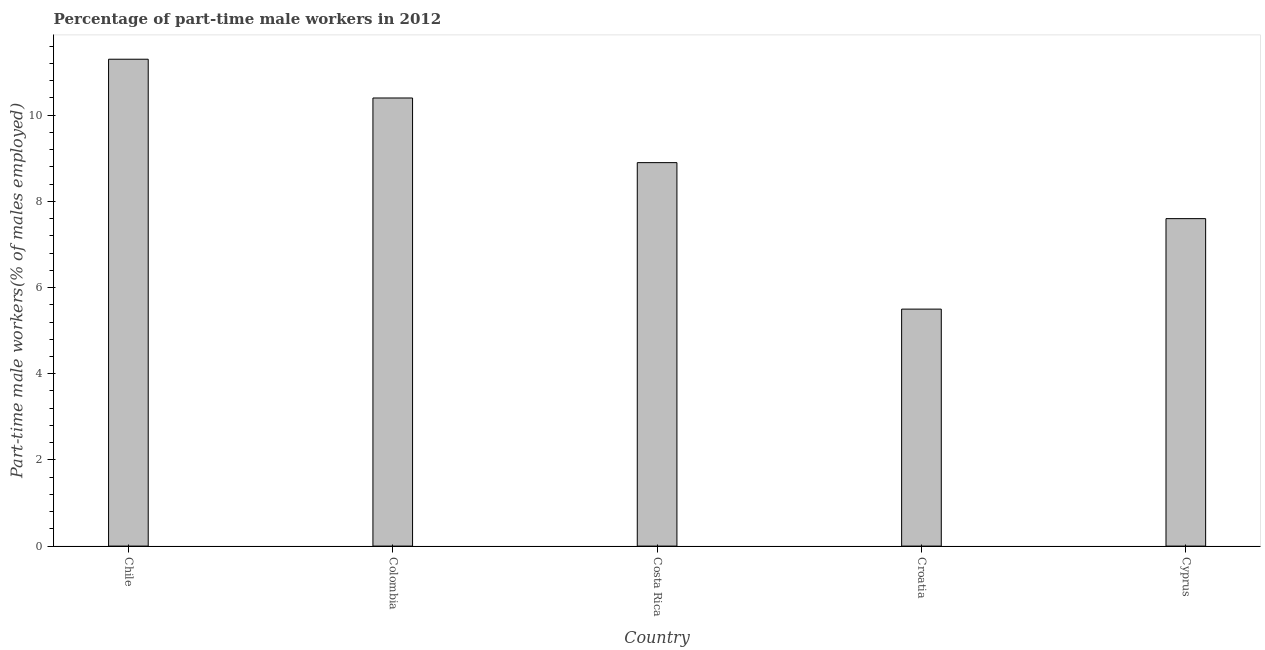What is the title of the graph?
Provide a succinct answer. Percentage of part-time male workers in 2012. What is the label or title of the Y-axis?
Your answer should be compact. Part-time male workers(% of males employed). Across all countries, what is the maximum percentage of part-time male workers?
Offer a terse response. 11.3. Across all countries, what is the minimum percentage of part-time male workers?
Offer a terse response. 5.5. In which country was the percentage of part-time male workers maximum?
Offer a terse response. Chile. In which country was the percentage of part-time male workers minimum?
Keep it short and to the point. Croatia. What is the sum of the percentage of part-time male workers?
Ensure brevity in your answer.  43.7. What is the average percentage of part-time male workers per country?
Offer a very short reply. 8.74. What is the median percentage of part-time male workers?
Ensure brevity in your answer.  8.9. What is the ratio of the percentage of part-time male workers in Chile to that in Croatia?
Offer a very short reply. 2.06. What is the difference between the highest and the second highest percentage of part-time male workers?
Make the answer very short. 0.9. Is the sum of the percentage of part-time male workers in Costa Rica and Croatia greater than the maximum percentage of part-time male workers across all countries?
Ensure brevity in your answer.  Yes. What is the difference between the highest and the lowest percentage of part-time male workers?
Offer a very short reply. 5.8. In how many countries, is the percentage of part-time male workers greater than the average percentage of part-time male workers taken over all countries?
Give a very brief answer. 3. How many bars are there?
Offer a very short reply. 5. What is the difference between two consecutive major ticks on the Y-axis?
Offer a terse response. 2. Are the values on the major ticks of Y-axis written in scientific E-notation?
Offer a terse response. No. What is the Part-time male workers(% of males employed) of Chile?
Your answer should be compact. 11.3. What is the Part-time male workers(% of males employed) of Colombia?
Make the answer very short. 10.4. What is the Part-time male workers(% of males employed) of Costa Rica?
Your answer should be very brief. 8.9. What is the Part-time male workers(% of males employed) of Croatia?
Provide a succinct answer. 5.5. What is the Part-time male workers(% of males employed) of Cyprus?
Offer a terse response. 7.6. What is the difference between the Part-time male workers(% of males employed) in Chile and Costa Rica?
Provide a short and direct response. 2.4. What is the difference between the Part-time male workers(% of males employed) in Chile and Croatia?
Your answer should be compact. 5.8. What is the difference between the Part-time male workers(% of males employed) in Chile and Cyprus?
Your answer should be compact. 3.7. What is the difference between the Part-time male workers(% of males employed) in Colombia and Costa Rica?
Offer a very short reply. 1.5. What is the difference between the Part-time male workers(% of males employed) in Costa Rica and Croatia?
Offer a terse response. 3.4. What is the ratio of the Part-time male workers(% of males employed) in Chile to that in Colombia?
Ensure brevity in your answer.  1.09. What is the ratio of the Part-time male workers(% of males employed) in Chile to that in Costa Rica?
Ensure brevity in your answer.  1.27. What is the ratio of the Part-time male workers(% of males employed) in Chile to that in Croatia?
Offer a terse response. 2.06. What is the ratio of the Part-time male workers(% of males employed) in Chile to that in Cyprus?
Offer a very short reply. 1.49. What is the ratio of the Part-time male workers(% of males employed) in Colombia to that in Costa Rica?
Your answer should be compact. 1.17. What is the ratio of the Part-time male workers(% of males employed) in Colombia to that in Croatia?
Your answer should be very brief. 1.89. What is the ratio of the Part-time male workers(% of males employed) in Colombia to that in Cyprus?
Provide a succinct answer. 1.37. What is the ratio of the Part-time male workers(% of males employed) in Costa Rica to that in Croatia?
Your answer should be compact. 1.62. What is the ratio of the Part-time male workers(% of males employed) in Costa Rica to that in Cyprus?
Offer a terse response. 1.17. What is the ratio of the Part-time male workers(% of males employed) in Croatia to that in Cyprus?
Offer a very short reply. 0.72. 